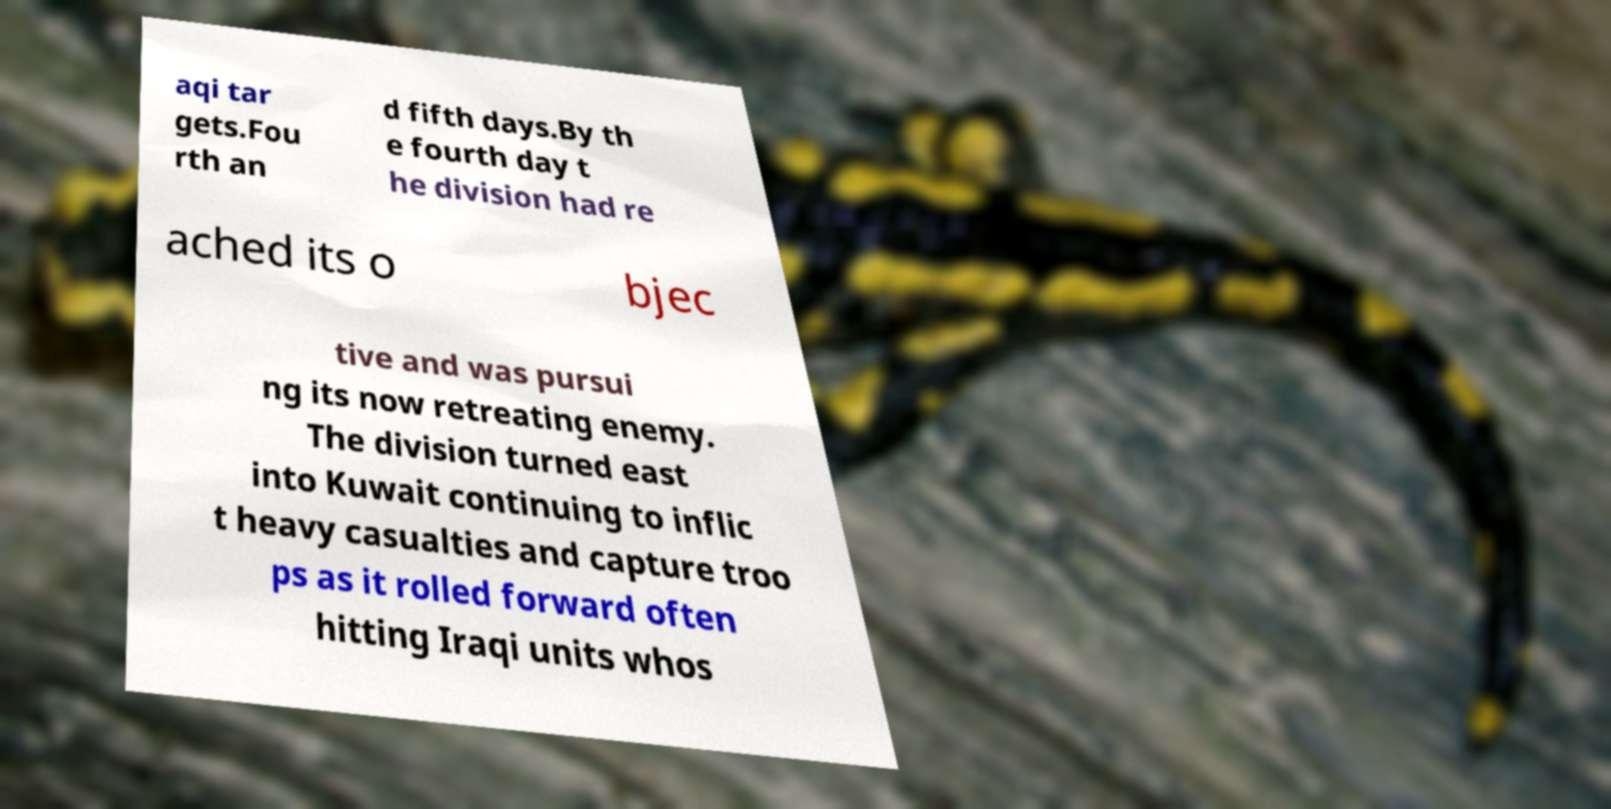What messages or text are displayed in this image? I need them in a readable, typed format. aqi tar gets.Fou rth an d fifth days.By th e fourth day t he division had re ached its o bjec tive and was pursui ng its now retreating enemy. The division turned east into Kuwait continuing to inflic t heavy casualties and capture troo ps as it rolled forward often hitting Iraqi units whos 